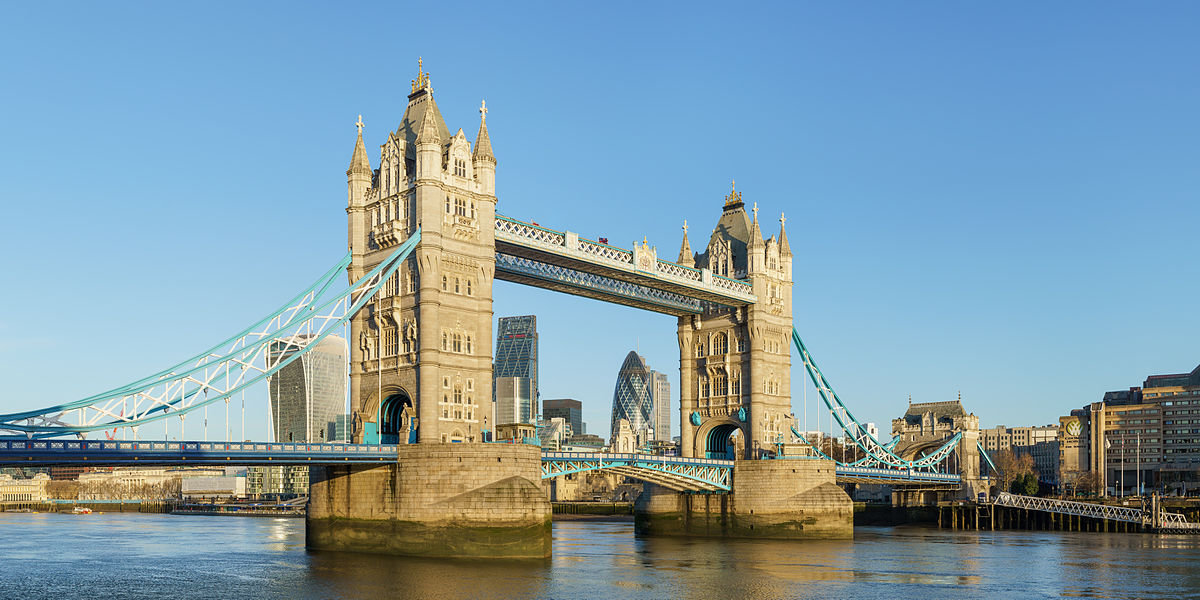What's happening in the scene? The image shows a clear, sunny day at London's Tower Bridge, a remarkable example of Victorian engineering. The bridge, known for its distinctive blue and white colors, stands over the tranquil Thames River. This image captures a normal day with no apparent events, just the usual calm flow of water beneath and some pedestrian and vehicular movement on the bridge, linking the two sides of the city. 